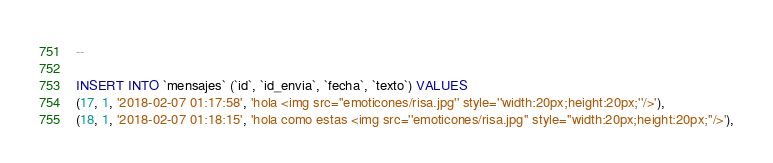Convert code to text. <code><loc_0><loc_0><loc_500><loc_500><_SQL_>--

INSERT INTO `mensajes` (`id`, `id_envia`, `fecha`, `texto`) VALUES
(17, 1, '2018-02-07 01:17:58', 'hola <img src=''emoticones/risa.jpg'' style=''width:20px;height:20px;''/>'),
(18, 1, '2018-02-07 01:18:15', 'hola como estas <img src=''emoticones/risa.jpg'' style=''width:20px;height:20px;''/>'),</code> 